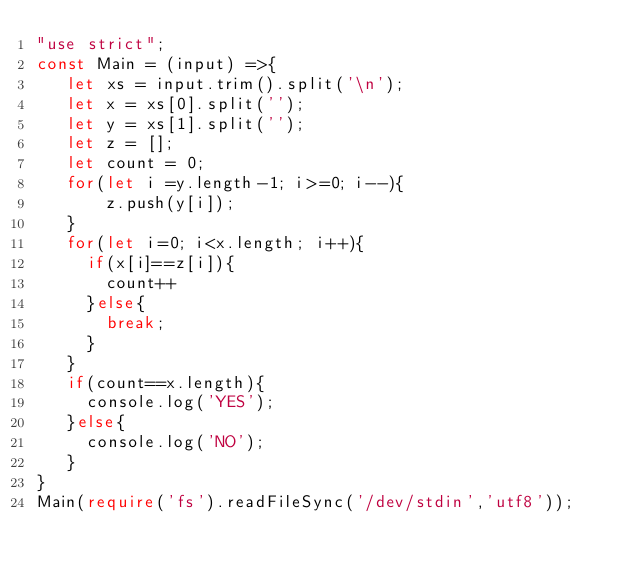Convert code to text. <code><loc_0><loc_0><loc_500><loc_500><_TypeScript_>"use strict";
const Main = (input) =>{
   let xs = input.trim().split('\n');
   let x = xs[0].split('');
   let y = xs[1].split('');
   let z = [];
   let count = 0;
   for(let i =y.length-1; i>=0; i--){
       z.push(y[i]);
   }
   for(let i=0; i<x.length; i++){
     if(x[i]==z[i]){
       count++
     }else{
       break;
     }
   }
   if(count==x.length){
     console.log('YES');
   }else{
     console.log('NO');
   }
}
Main(require('fs').readFileSync('/dev/stdin','utf8'));


</code> 